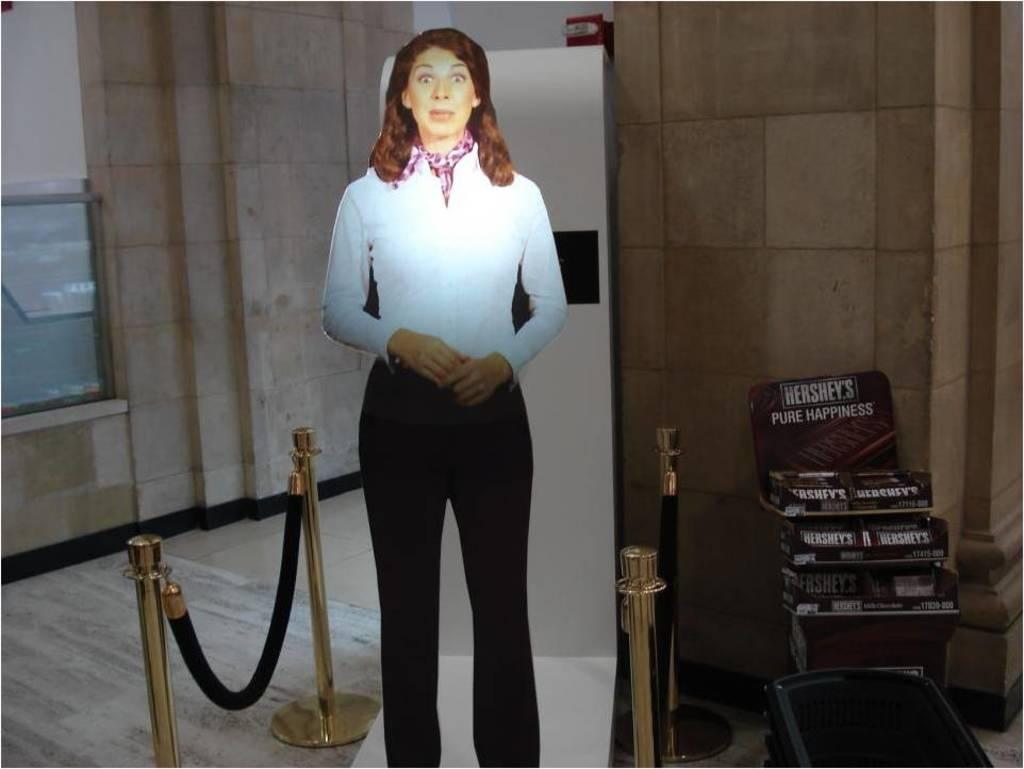Provide a one-sentence caption for the provided image. A cardboard cutout of a surprised woman stands next to a display of Hershey's chocolate bars. 